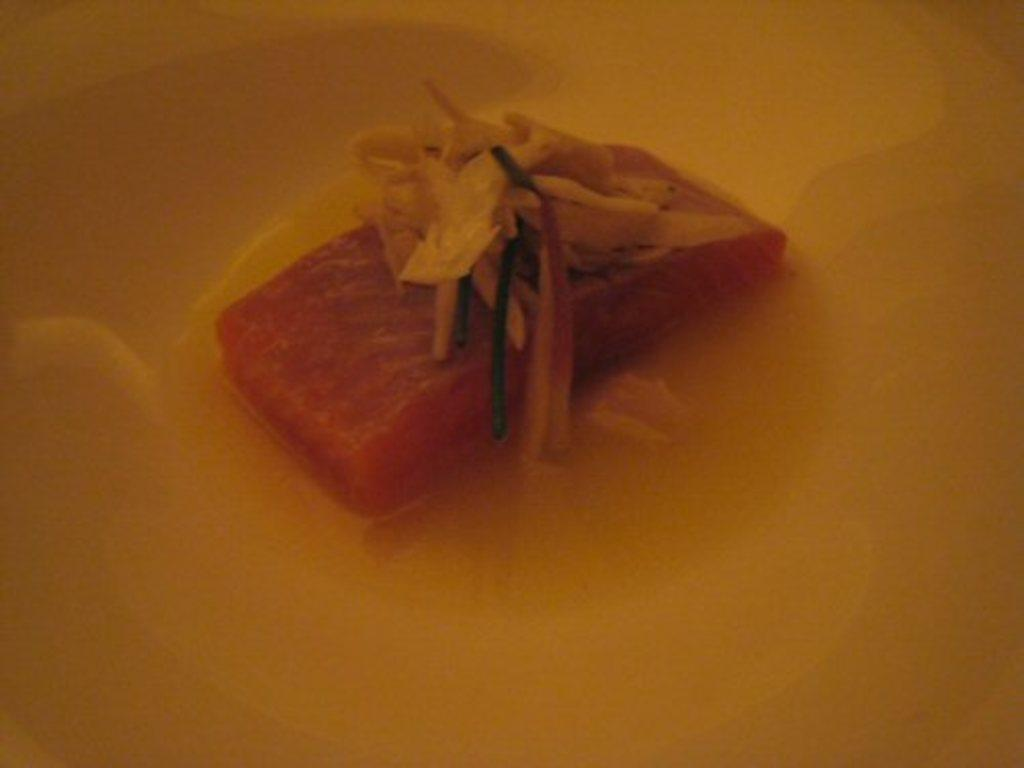What type of fish is present in the image? There is a piece of salmon fish in the image. What else can be seen in the image besides the fish? There is soup in the image. What color is the scarf that is draped over the silver bowl in the image? There is no scarf or silver bowl present in the image. 